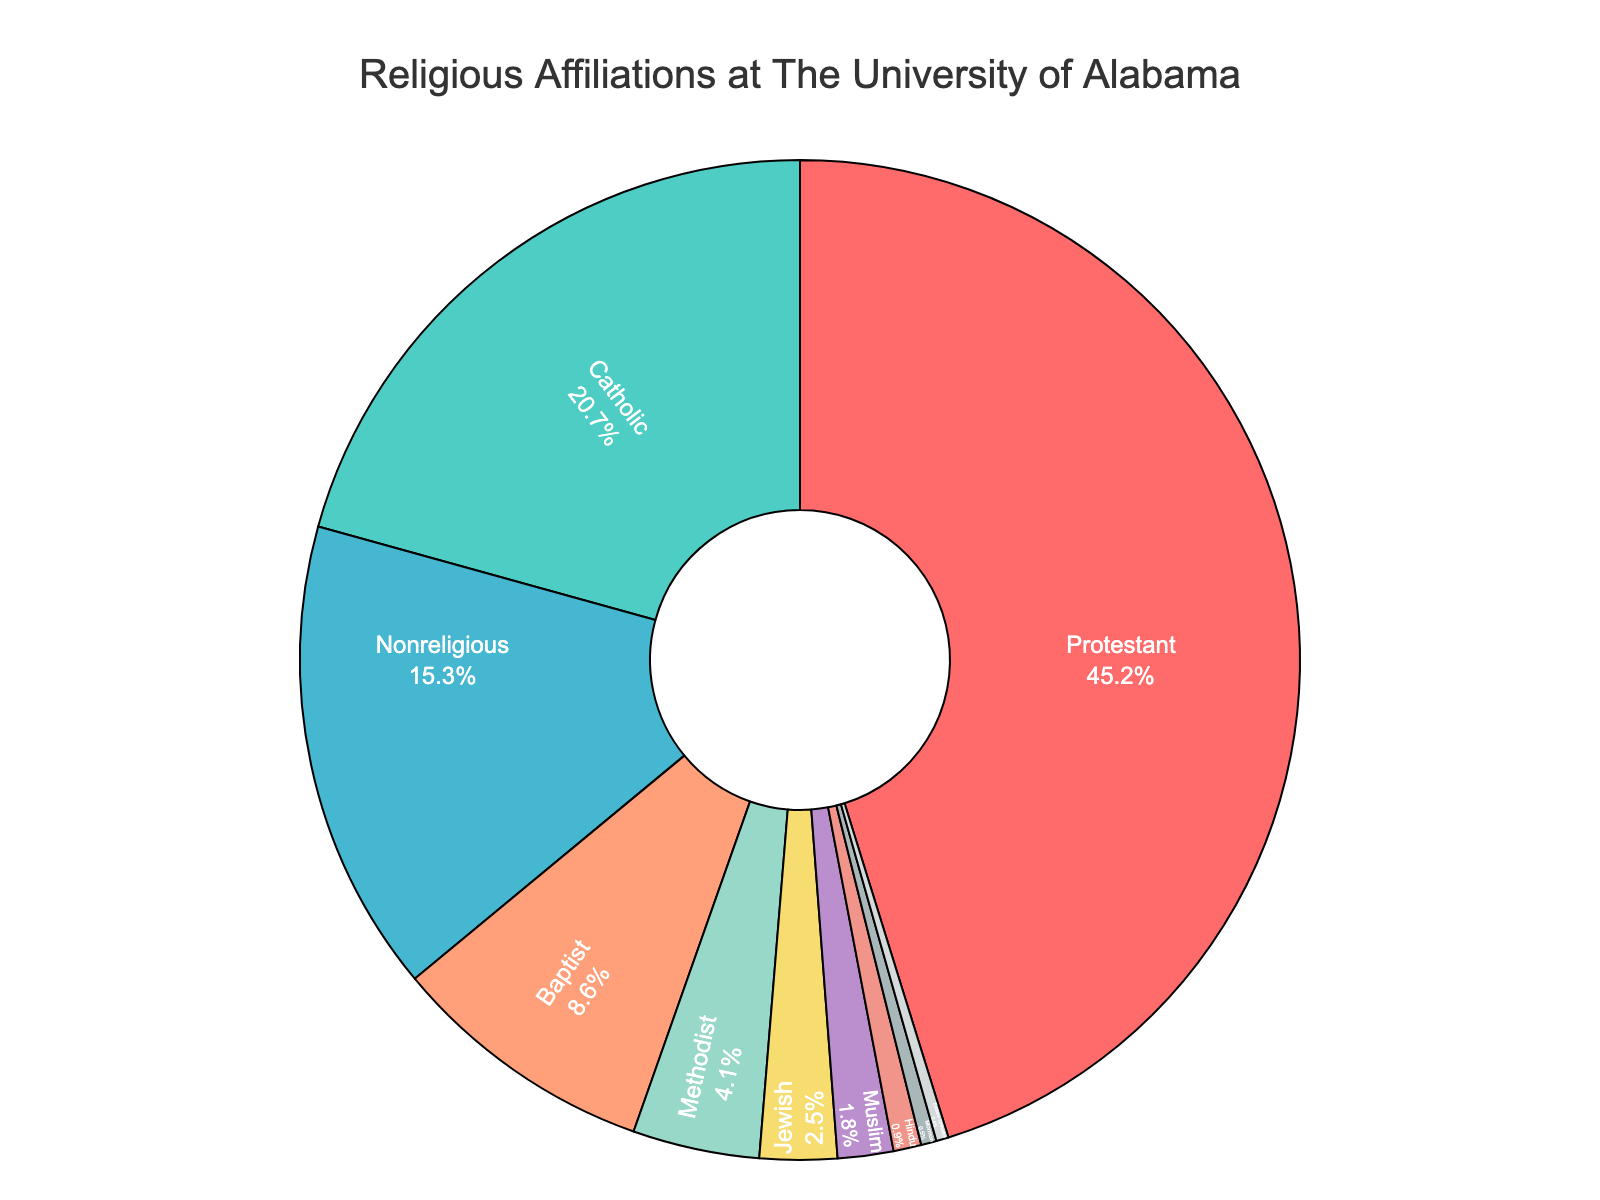Which religious affiliation has the largest percentage? Referring to the pie chart, the largest segment is colored red, representing Protestant, which has the highest percentage.
Answer: Protestant Which religious affiliation has the smallest percentage? Referring to the chart, the smallest segment is colored gray, indicating Eastern Orthodox, which has the lowest percentage.
Answer: Eastern Orthodox What is the combined percentage of Protestant and Catholic affiliations? By adding the percentage of Protestants (45.2%) and Catholics (20.7%), the combined percentage is 45.2 + 20.7.
Answer: 65.9% Which religious affiliations have percentages below 5%? Looking at the smaller segments in the pie chart, Methodist, Jewish, Muslim, Hindu, Mormon, and Eastern Orthodox all have percentages below 5%.
Answer: Methodist, Jewish, Muslim, Hindu, Mormon, Eastern Orthodox What is the difference in percentage between Protestant and Nonreligious affiliations? Protestant has 45.2% and the Nonreligious group has 15.3%. Subtracting these gives 45.2 - 15.3.
Answer: 29.9% Which two religious affiliations have the closest percentages? Referring to the pie chart, the closest percentages are Methodist (4.1%) and Jewish (2.5%), but the smallest difference is between Muslim (1.8%) and Jewish (2.5%), a difference of 0.7%.
Answer: Muslim and Jewish How many affiliations have percentages higher than 10%? Referring to the pie chart, Protestant (45.2%) and Catholic (20.7%) are the only affiliations above 10%.
Answer: 2 What is the average percentage of the three least common religious affiliations? The percentages are Eastern Orthodox (0.4%), Mormon (0.5%), and Hindu (0.9%). Averaging these (0.4 + 0.5 + 0.9) / 3.
Answer: 0.6% What is the visual attribute of the Catholic affiliation segment? The pie chart represents Catholic with a different color (green) and it occupies a notable portion of the chart (20.7%).
Answer: Green and 20.7% Are there more Protestant students than Nonreligious, Baptist, and Methodist combined? Adding the Nonreligious (15.3%), Baptist (8.6%), and Methodist (4.1%) gives 15.3 + 8.6 + 4.1 = 28.0%, which is less than the Protestant percentage (45.2%).
Answer: Yes 